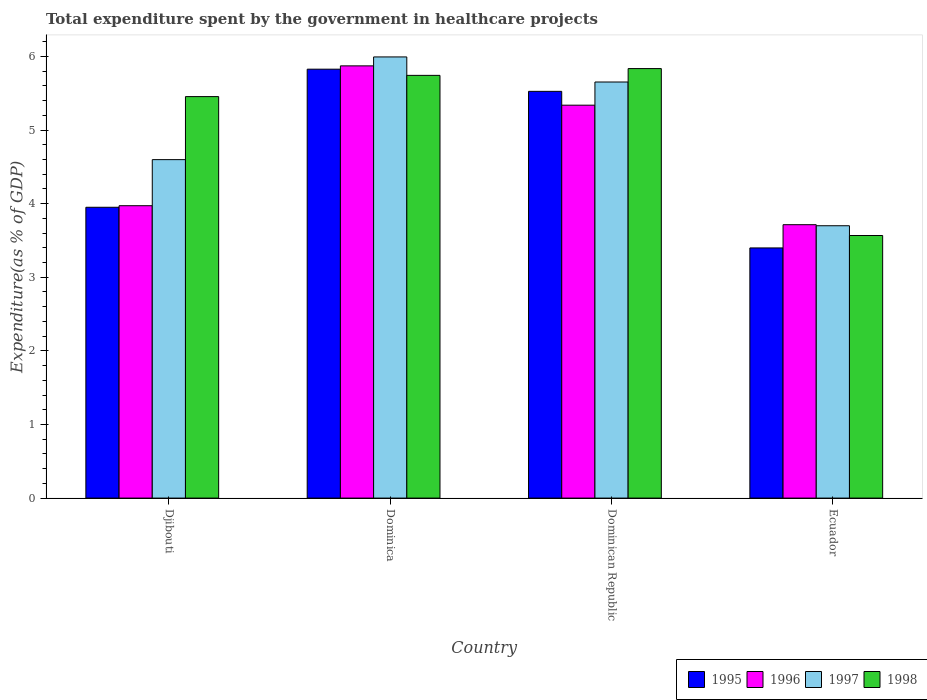What is the label of the 4th group of bars from the left?
Ensure brevity in your answer.  Ecuador. In how many cases, is the number of bars for a given country not equal to the number of legend labels?
Ensure brevity in your answer.  0. What is the total expenditure spent by the government in healthcare projects in 1997 in Ecuador?
Ensure brevity in your answer.  3.7. Across all countries, what is the maximum total expenditure spent by the government in healthcare projects in 1998?
Offer a very short reply. 5.84. Across all countries, what is the minimum total expenditure spent by the government in healthcare projects in 1996?
Offer a very short reply. 3.71. In which country was the total expenditure spent by the government in healthcare projects in 1996 maximum?
Make the answer very short. Dominica. In which country was the total expenditure spent by the government in healthcare projects in 1997 minimum?
Your response must be concise. Ecuador. What is the total total expenditure spent by the government in healthcare projects in 1997 in the graph?
Provide a short and direct response. 19.94. What is the difference between the total expenditure spent by the government in healthcare projects in 1996 in Djibouti and that in Dominican Republic?
Keep it short and to the point. -1.37. What is the difference between the total expenditure spent by the government in healthcare projects in 1998 in Ecuador and the total expenditure spent by the government in healthcare projects in 1995 in Djibouti?
Provide a short and direct response. -0.38. What is the average total expenditure spent by the government in healthcare projects in 1998 per country?
Provide a succinct answer. 5.15. What is the difference between the total expenditure spent by the government in healthcare projects of/in 1995 and total expenditure spent by the government in healthcare projects of/in 1996 in Djibouti?
Keep it short and to the point. -0.02. What is the ratio of the total expenditure spent by the government in healthcare projects in 1996 in Djibouti to that in Ecuador?
Offer a terse response. 1.07. Is the total expenditure spent by the government in healthcare projects in 1996 in Dominica less than that in Dominican Republic?
Give a very brief answer. No. Is the difference between the total expenditure spent by the government in healthcare projects in 1995 in Dominica and Ecuador greater than the difference between the total expenditure spent by the government in healthcare projects in 1996 in Dominica and Ecuador?
Ensure brevity in your answer.  Yes. What is the difference between the highest and the second highest total expenditure spent by the government in healthcare projects in 1997?
Provide a succinct answer. 1.05. What is the difference between the highest and the lowest total expenditure spent by the government in healthcare projects in 1995?
Your response must be concise. 2.43. What does the 2nd bar from the left in Dominican Republic represents?
Your answer should be very brief. 1996. How many bars are there?
Your answer should be compact. 16. Does the graph contain any zero values?
Make the answer very short. No. Does the graph contain grids?
Provide a succinct answer. No. Where does the legend appear in the graph?
Provide a succinct answer. Bottom right. What is the title of the graph?
Your response must be concise. Total expenditure spent by the government in healthcare projects. Does "1996" appear as one of the legend labels in the graph?
Your response must be concise. Yes. What is the label or title of the Y-axis?
Keep it short and to the point. Expenditure(as % of GDP). What is the Expenditure(as % of GDP) in 1995 in Djibouti?
Offer a very short reply. 3.95. What is the Expenditure(as % of GDP) in 1996 in Djibouti?
Your response must be concise. 3.97. What is the Expenditure(as % of GDP) of 1997 in Djibouti?
Provide a succinct answer. 4.6. What is the Expenditure(as % of GDP) of 1998 in Djibouti?
Ensure brevity in your answer.  5.45. What is the Expenditure(as % of GDP) in 1995 in Dominica?
Offer a terse response. 5.83. What is the Expenditure(as % of GDP) in 1996 in Dominica?
Keep it short and to the point. 5.87. What is the Expenditure(as % of GDP) in 1997 in Dominica?
Ensure brevity in your answer.  5.99. What is the Expenditure(as % of GDP) of 1998 in Dominica?
Give a very brief answer. 5.74. What is the Expenditure(as % of GDP) of 1995 in Dominican Republic?
Provide a succinct answer. 5.53. What is the Expenditure(as % of GDP) of 1996 in Dominican Republic?
Your response must be concise. 5.34. What is the Expenditure(as % of GDP) of 1997 in Dominican Republic?
Ensure brevity in your answer.  5.65. What is the Expenditure(as % of GDP) in 1998 in Dominican Republic?
Your answer should be very brief. 5.84. What is the Expenditure(as % of GDP) of 1995 in Ecuador?
Offer a terse response. 3.4. What is the Expenditure(as % of GDP) of 1996 in Ecuador?
Give a very brief answer. 3.71. What is the Expenditure(as % of GDP) in 1997 in Ecuador?
Make the answer very short. 3.7. What is the Expenditure(as % of GDP) in 1998 in Ecuador?
Provide a short and direct response. 3.57. Across all countries, what is the maximum Expenditure(as % of GDP) of 1995?
Ensure brevity in your answer.  5.83. Across all countries, what is the maximum Expenditure(as % of GDP) of 1996?
Make the answer very short. 5.87. Across all countries, what is the maximum Expenditure(as % of GDP) of 1997?
Provide a short and direct response. 5.99. Across all countries, what is the maximum Expenditure(as % of GDP) in 1998?
Your answer should be compact. 5.84. Across all countries, what is the minimum Expenditure(as % of GDP) of 1995?
Provide a short and direct response. 3.4. Across all countries, what is the minimum Expenditure(as % of GDP) of 1996?
Ensure brevity in your answer.  3.71. Across all countries, what is the minimum Expenditure(as % of GDP) of 1997?
Your answer should be compact. 3.7. Across all countries, what is the minimum Expenditure(as % of GDP) in 1998?
Offer a very short reply. 3.57. What is the total Expenditure(as % of GDP) in 1995 in the graph?
Your answer should be compact. 18.7. What is the total Expenditure(as % of GDP) in 1996 in the graph?
Provide a short and direct response. 18.9. What is the total Expenditure(as % of GDP) in 1997 in the graph?
Your answer should be very brief. 19.94. What is the total Expenditure(as % of GDP) in 1998 in the graph?
Provide a short and direct response. 20.6. What is the difference between the Expenditure(as % of GDP) of 1995 in Djibouti and that in Dominica?
Give a very brief answer. -1.88. What is the difference between the Expenditure(as % of GDP) of 1997 in Djibouti and that in Dominica?
Provide a succinct answer. -1.4. What is the difference between the Expenditure(as % of GDP) in 1998 in Djibouti and that in Dominica?
Offer a terse response. -0.29. What is the difference between the Expenditure(as % of GDP) in 1995 in Djibouti and that in Dominican Republic?
Ensure brevity in your answer.  -1.57. What is the difference between the Expenditure(as % of GDP) of 1996 in Djibouti and that in Dominican Republic?
Your answer should be compact. -1.37. What is the difference between the Expenditure(as % of GDP) of 1997 in Djibouti and that in Dominican Republic?
Your answer should be very brief. -1.05. What is the difference between the Expenditure(as % of GDP) in 1998 in Djibouti and that in Dominican Republic?
Your answer should be very brief. -0.38. What is the difference between the Expenditure(as % of GDP) of 1995 in Djibouti and that in Ecuador?
Your response must be concise. 0.55. What is the difference between the Expenditure(as % of GDP) of 1996 in Djibouti and that in Ecuador?
Your response must be concise. 0.26. What is the difference between the Expenditure(as % of GDP) in 1997 in Djibouti and that in Ecuador?
Offer a very short reply. 0.9. What is the difference between the Expenditure(as % of GDP) in 1998 in Djibouti and that in Ecuador?
Your answer should be very brief. 1.89. What is the difference between the Expenditure(as % of GDP) of 1995 in Dominica and that in Dominican Republic?
Offer a terse response. 0.3. What is the difference between the Expenditure(as % of GDP) in 1996 in Dominica and that in Dominican Republic?
Give a very brief answer. 0.53. What is the difference between the Expenditure(as % of GDP) in 1997 in Dominica and that in Dominican Republic?
Give a very brief answer. 0.34. What is the difference between the Expenditure(as % of GDP) of 1998 in Dominica and that in Dominican Republic?
Give a very brief answer. -0.09. What is the difference between the Expenditure(as % of GDP) of 1995 in Dominica and that in Ecuador?
Provide a succinct answer. 2.43. What is the difference between the Expenditure(as % of GDP) of 1996 in Dominica and that in Ecuador?
Offer a very short reply. 2.16. What is the difference between the Expenditure(as % of GDP) in 1997 in Dominica and that in Ecuador?
Offer a very short reply. 2.29. What is the difference between the Expenditure(as % of GDP) in 1998 in Dominica and that in Ecuador?
Keep it short and to the point. 2.18. What is the difference between the Expenditure(as % of GDP) of 1995 in Dominican Republic and that in Ecuador?
Provide a succinct answer. 2.13. What is the difference between the Expenditure(as % of GDP) of 1996 in Dominican Republic and that in Ecuador?
Ensure brevity in your answer.  1.62. What is the difference between the Expenditure(as % of GDP) of 1997 in Dominican Republic and that in Ecuador?
Ensure brevity in your answer.  1.95. What is the difference between the Expenditure(as % of GDP) of 1998 in Dominican Republic and that in Ecuador?
Your answer should be compact. 2.27. What is the difference between the Expenditure(as % of GDP) in 1995 in Djibouti and the Expenditure(as % of GDP) in 1996 in Dominica?
Offer a terse response. -1.92. What is the difference between the Expenditure(as % of GDP) of 1995 in Djibouti and the Expenditure(as % of GDP) of 1997 in Dominica?
Offer a very short reply. -2.04. What is the difference between the Expenditure(as % of GDP) of 1995 in Djibouti and the Expenditure(as % of GDP) of 1998 in Dominica?
Provide a succinct answer. -1.79. What is the difference between the Expenditure(as % of GDP) of 1996 in Djibouti and the Expenditure(as % of GDP) of 1997 in Dominica?
Your answer should be compact. -2.02. What is the difference between the Expenditure(as % of GDP) in 1996 in Djibouti and the Expenditure(as % of GDP) in 1998 in Dominica?
Ensure brevity in your answer.  -1.77. What is the difference between the Expenditure(as % of GDP) in 1997 in Djibouti and the Expenditure(as % of GDP) in 1998 in Dominica?
Provide a short and direct response. -1.14. What is the difference between the Expenditure(as % of GDP) of 1995 in Djibouti and the Expenditure(as % of GDP) of 1996 in Dominican Republic?
Your answer should be compact. -1.39. What is the difference between the Expenditure(as % of GDP) in 1995 in Djibouti and the Expenditure(as % of GDP) in 1997 in Dominican Republic?
Provide a short and direct response. -1.7. What is the difference between the Expenditure(as % of GDP) of 1995 in Djibouti and the Expenditure(as % of GDP) of 1998 in Dominican Republic?
Make the answer very short. -1.88. What is the difference between the Expenditure(as % of GDP) in 1996 in Djibouti and the Expenditure(as % of GDP) in 1997 in Dominican Republic?
Provide a succinct answer. -1.68. What is the difference between the Expenditure(as % of GDP) of 1996 in Djibouti and the Expenditure(as % of GDP) of 1998 in Dominican Republic?
Provide a succinct answer. -1.86. What is the difference between the Expenditure(as % of GDP) in 1997 in Djibouti and the Expenditure(as % of GDP) in 1998 in Dominican Republic?
Provide a succinct answer. -1.24. What is the difference between the Expenditure(as % of GDP) in 1995 in Djibouti and the Expenditure(as % of GDP) in 1996 in Ecuador?
Ensure brevity in your answer.  0.24. What is the difference between the Expenditure(as % of GDP) of 1995 in Djibouti and the Expenditure(as % of GDP) of 1997 in Ecuador?
Give a very brief answer. 0.25. What is the difference between the Expenditure(as % of GDP) of 1995 in Djibouti and the Expenditure(as % of GDP) of 1998 in Ecuador?
Ensure brevity in your answer.  0.38. What is the difference between the Expenditure(as % of GDP) in 1996 in Djibouti and the Expenditure(as % of GDP) in 1997 in Ecuador?
Make the answer very short. 0.27. What is the difference between the Expenditure(as % of GDP) of 1996 in Djibouti and the Expenditure(as % of GDP) of 1998 in Ecuador?
Your answer should be compact. 0.4. What is the difference between the Expenditure(as % of GDP) in 1997 in Djibouti and the Expenditure(as % of GDP) in 1998 in Ecuador?
Your answer should be very brief. 1.03. What is the difference between the Expenditure(as % of GDP) of 1995 in Dominica and the Expenditure(as % of GDP) of 1996 in Dominican Republic?
Provide a short and direct response. 0.49. What is the difference between the Expenditure(as % of GDP) in 1995 in Dominica and the Expenditure(as % of GDP) in 1997 in Dominican Republic?
Your answer should be compact. 0.17. What is the difference between the Expenditure(as % of GDP) in 1995 in Dominica and the Expenditure(as % of GDP) in 1998 in Dominican Republic?
Offer a terse response. -0.01. What is the difference between the Expenditure(as % of GDP) in 1996 in Dominica and the Expenditure(as % of GDP) in 1997 in Dominican Republic?
Provide a succinct answer. 0.22. What is the difference between the Expenditure(as % of GDP) in 1996 in Dominica and the Expenditure(as % of GDP) in 1998 in Dominican Republic?
Ensure brevity in your answer.  0.04. What is the difference between the Expenditure(as % of GDP) of 1997 in Dominica and the Expenditure(as % of GDP) of 1998 in Dominican Republic?
Provide a succinct answer. 0.16. What is the difference between the Expenditure(as % of GDP) in 1995 in Dominica and the Expenditure(as % of GDP) in 1996 in Ecuador?
Offer a very short reply. 2.11. What is the difference between the Expenditure(as % of GDP) in 1995 in Dominica and the Expenditure(as % of GDP) in 1997 in Ecuador?
Provide a succinct answer. 2.13. What is the difference between the Expenditure(as % of GDP) in 1995 in Dominica and the Expenditure(as % of GDP) in 1998 in Ecuador?
Your answer should be compact. 2.26. What is the difference between the Expenditure(as % of GDP) of 1996 in Dominica and the Expenditure(as % of GDP) of 1997 in Ecuador?
Make the answer very short. 2.17. What is the difference between the Expenditure(as % of GDP) of 1996 in Dominica and the Expenditure(as % of GDP) of 1998 in Ecuador?
Your answer should be compact. 2.3. What is the difference between the Expenditure(as % of GDP) of 1997 in Dominica and the Expenditure(as % of GDP) of 1998 in Ecuador?
Give a very brief answer. 2.43. What is the difference between the Expenditure(as % of GDP) of 1995 in Dominican Republic and the Expenditure(as % of GDP) of 1996 in Ecuador?
Your answer should be very brief. 1.81. What is the difference between the Expenditure(as % of GDP) of 1995 in Dominican Republic and the Expenditure(as % of GDP) of 1997 in Ecuador?
Ensure brevity in your answer.  1.83. What is the difference between the Expenditure(as % of GDP) in 1995 in Dominican Republic and the Expenditure(as % of GDP) in 1998 in Ecuador?
Provide a short and direct response. 1.96. What is the difference between the Expenditure(as % of GDP) of 1996 in Dominican Republic and the Expenditure(as % of GDP) of 1997 in Ecuador?
Your response must be concise. 1.64. What is the difference between the Expenditure(as % of GDP) of 1996 in Dominican Republic and the Expenditure(as % of GDP) of 1998 in Ecuador?
Ensure brevity in your answer.  1.77. What is the difference between the Expenditure(as % of GDP) of 1997 in Dominican Republic and the Expenditure(as % of GDP) of 1998 in Ecuador?
Your response must be concise. 2.09. What is the average Expenditure(as % of GDP) in 1995 per country?
Make the answer very short. 4.68. What is the average Expenditure(as % of GDP) in 1996 per country?
Offer a very short reply. 4.72. What is the average Expenditure(as % of GDP) in 1997 per country?
Your answer should be very brief. 4.99. What is the average Expenditure(as % of GDP) in 1998 per country?
Ensure brevity in your answer.  5.15. What is the difference between the Expenditure(as % of GDP) of 1995 and Expenditure(as % of GDP) of 1996 in Djibouti?
Offer a very short reply. -0.02. What is the difference between the Expenditure(as % of GDP) in 1995 and Expenditure(as % of GDP) in 1997 in Djibouti?
Ensure brevity in your answer.  -0.65. What is the difference between the Expenditure(as % of GDP) in 1995 and Expenditure(as % of GDP) in 1998 in Djibouti?
Give a very brief answer. -1.5. What is the difference between the Expenditure(as % of GDP) of 1996 and Expenditure(as % of GDP) of 1997 in Djibouti?
Provide a succinct answer. -0.63. What is the difference between the Expenditure(as % of GDP) in 1996 and Expenditure(as % of GDP) in 1998 in Djibouti?
Your response must be concise. -1.48. What is the difference between the Expenditure(as % of GDP) in 1997 and Expenditure(as % of GDP) in 1998 in Djibouti?
Make the answer very short. -0.86. What is the difference between the Expenditure(as % of GDP) of 1995 and Expenditure(as % of GDP) of 1996 in Dominica?
Offer a very short reply. -0.05. What is the difference between the Expenditure(as % of GDP) of 1995 and Expenditure(as % of GDP) of 1997 in Dominica?
Provide a short and direct response. -0.17. What is the difference between the Expenditure(as % of GDP) of 1995 and Expenditure(as % of GDP) of 1998 in Dominica?
Make the answer very short. 0.08. What is the difference between the Expenditure(as % of GDP) in 1996 and Expenditure(as % of GDP) in 1997 in Dominica?
Give a very brief answer. -0.12. What is the difference between the Expenditure(as % of GDP) in 1996 and Expenditure(as % of GDP) in 1998 in Dominica?
Keep it short and to the point. 0.13. What is the difference between the Expenditure(as % of GDP) of 1997 and Expenditure(as % of GDP) of 1998 in Dominica?
Ensure brevity in your answer.  0.25. What is the difference between the Expenditure(as % of GDP) of 1995 and Expenditure(as % of GDP) of 1996 in Dominican Republic?
Your answer should be compact. 0.19. What is the difference between the Expenditure(as % of GDP) in 1995 and Expenditure(as % of GDP) in 1997 in Dominican Republic?
Your response must be concise. -0.13. What is the difference between the Expenditure(as % of GDP) of 1995 and Expenditure(as % of GDP) of 1998 in Dominican Republic?
Keep it short and to the point. -0.31. What is the difference between the Expenditure(as % of GDP) in 1996 and Expenditure(as % of GDP) in 1997 in Dominican Republic?
Offer a terse response. -0.31. What is the difference between the Expenditure(as % of GDP) of 1996 and Expenditure(as % of GDP) of 1998 in Dominican Republic?
Give a very brief answer. -0.5. What is the difference between the Expenditure(as % of GDP) in 1997 and Expenditure(as % of GDP) in 1998 in Dominican Republic?
Your answer should be very brief. -0.18. What is the difference between the Expenditure(as % of GDP) in 1995 and Expenditure(as % of GDP) in 1996 in Ecuador?
Provide a short and direct response. -0.32. What is the difference between the Expenditure(as % of GDP) of 1995 and Expenditure(as % of GDP) of 1997 in Ecuador?
Ensure brevity in your answer.  -0.3. What is the difference between the Expenditure(as % of GDP) of 1995 and Expenditure(as % of GDP) of 1998 in Ecuador?
Offer a very short reply. -0.17. What is the difference between the Expenditure(as % of GDP) of 1996 and Expenditure(as % of GDP) of 1997 in Ecuador?
Offer a very short reply. 0.01. What is the difference between the Expenditure(as % of GDP) of 1996 and Expenditure(as % of GDP) of 1998 in Ecuador?
Make the answer very short. 0.15. What is the difference between the Expenditure(as % of GDP) of 1997 and Expenditure(as % of GDP) of 1998 in Ecuador?
Give a very brief answer. 0.13. What is the ratio of the Expenditure(as % of GDP) of 1995 in Djibouti to that in Dominica?
Offer a very short reply. 0.68. What is the ratio of the Expenditure(as % of GDP) in 1996 in Djibouti to that in Dominica?
Your answer should be compact. 0.68. What is the ratio of the Expenditure(as % of GDP) in 1997 in Djibouti to that in Dominica?
Provide a succinct answer. 0.77. What is the ratio of the Expenditure(as % of GDP) in 1998 in Djibouti to that in Dominica?
Your answer should be very brief. 0.95. What is the ratio of the Expenditure(as % of GDP) in 1995 in Djibouti to that in Dominican Republic?
Keep it short and to the point. 0.71. What is the ratio of the Expenditure(as % of GDP) of 1996 in Djibouti to that in Dominican Republic?
Your answer should be very brief. 0.74. What is the ratio of the Expenditure(as % of GDP) in 1997 in Djibouti to that in Dominican Republic?
Give a very brief answer. 0.81. What is the ratio of the Expenditure(as % of GDP) of 1998 in Djibouti to that in Dominican Republic?
Offer a very short reply. 0.93. What is the ratio of the Expenditure(as % of GDP) of 1995 in Djibouti to that in Ecuador?
Ensure brevity in your answer.  1.16. What is the ratio of the Expenditure(as % of GDP) in 1996 in Djibouti to that in Ecuador?
Your answer should be compact. 1.07. What is the ratio of the Expenditure(as % of GDP) in 1997 in Djibouti to that in Ecuador?
Offer a very short reply. 1.24. What is the ratio of the Expenditure(as % of GDP) in 1998 in Djibouti to that in Ecuador?
Your answer should be very brief. 1.53. What is the ratio of the Expenditure(as % of GDP) of 1995 in Dominica to that in Dominican Republic?
Offer a very short reply. 1.05. What is the ratio of the Expenditure(as % of GDP) of 1997 in Dominica to that in Dominican Republic?
Your answer should be very brief. 1.06. What is the ratio of the Expenditure(as % of GDP) in 1998 in Dominica to that in Dominican Republic?
Ensure brevity in your answer.  0.98. What is the ratio of the Expenditure(as % of GDP) of 1995 in Dominica to that in Ecuador?
Offer a very short reply. 1.71. What is the ratio of the Expenditure(as % of GDP) of 1996 in Dominica to that in Ecuador?
Keep it short and to the point. 1.58. What is the ratio of the Expenditure(as % of GDP) in 1997 in Dominica to that in Ecuador?
Your answer should be very brief. 1.62. What is the ratio of the Expenditure(as % of GDP) of 1998 in Dominica to that in Ecuador?
Your answer should be very brief. 1.61. What is the ratio of the Expenditure(as % of GDP) of 1995 in Dominican Republic to that in Ecuador?
Offer a very short reply. 1.63. What is the ratio of the Expenditure(as % of GDP) in 1996 in Dominican Republic to that in Ecuador?
Your answer should be very brief. 1.44. What is the ratio of the Expenditure(as % of GDP) of 1997 in Dominican Republic to that in Ecuador?
Your response must be concise. 1.53. What is the ratio of the Expenditure(as % of GDP) in 1998 in Dominican Republic to that in Ecuador?
Your answer should be compact. 1.64. What is the difference between the highest and the second highest Expenditure(as % of GDP) in 1995?
Offer a terse response. 0.3. What is the difference between the highest and the second highest Expenditure(as % of GDP) in 1996?
Provide a short and direct response. 0.53. What is the difference between the highest and the second highest Expenditure(as % of GDP) of 1997?
Keep it short and to the point. 0.34. What is the difference between the highest and the second highest Expenditure(as % of GDP) in 1998?
Give a very brief answer. 0.09. What is the difference between the highest and the lowest Expenditure(as % of GDP) of 1995?
Your answer should be compact. 2.43. What is the difference between the highest and the lowest Expenditure(as % of GDP) in 1996?
Keep it short and to the point. 2.16. What is the difference between the highest and the lowest Expenditure(as % of GDP) of 1997?
Keep it short and to the point. 2.29. What is the difference between the highest and the lowest Expenditure(as % of GDP) of 1998?
Provide a short and direct response. 2.27. 